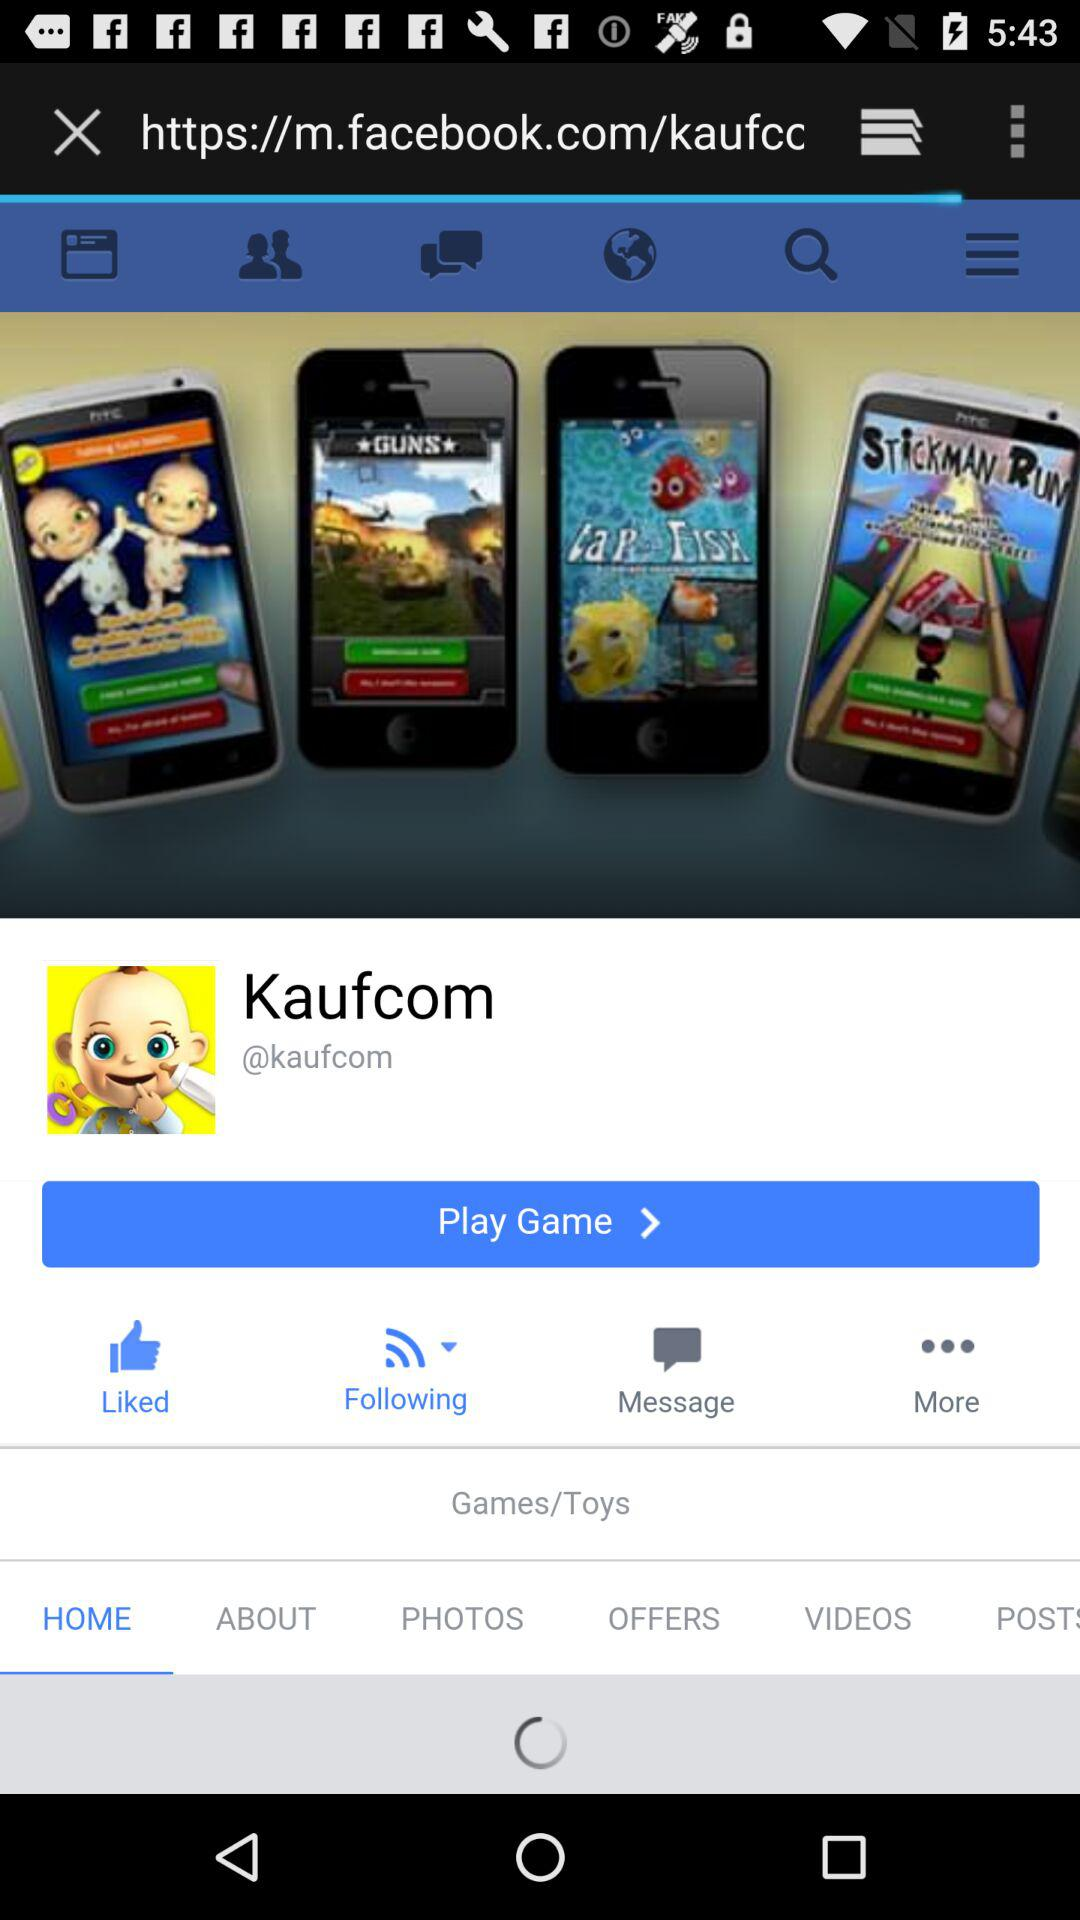What is the name of the game? The name of the game is "Kaufcom". 